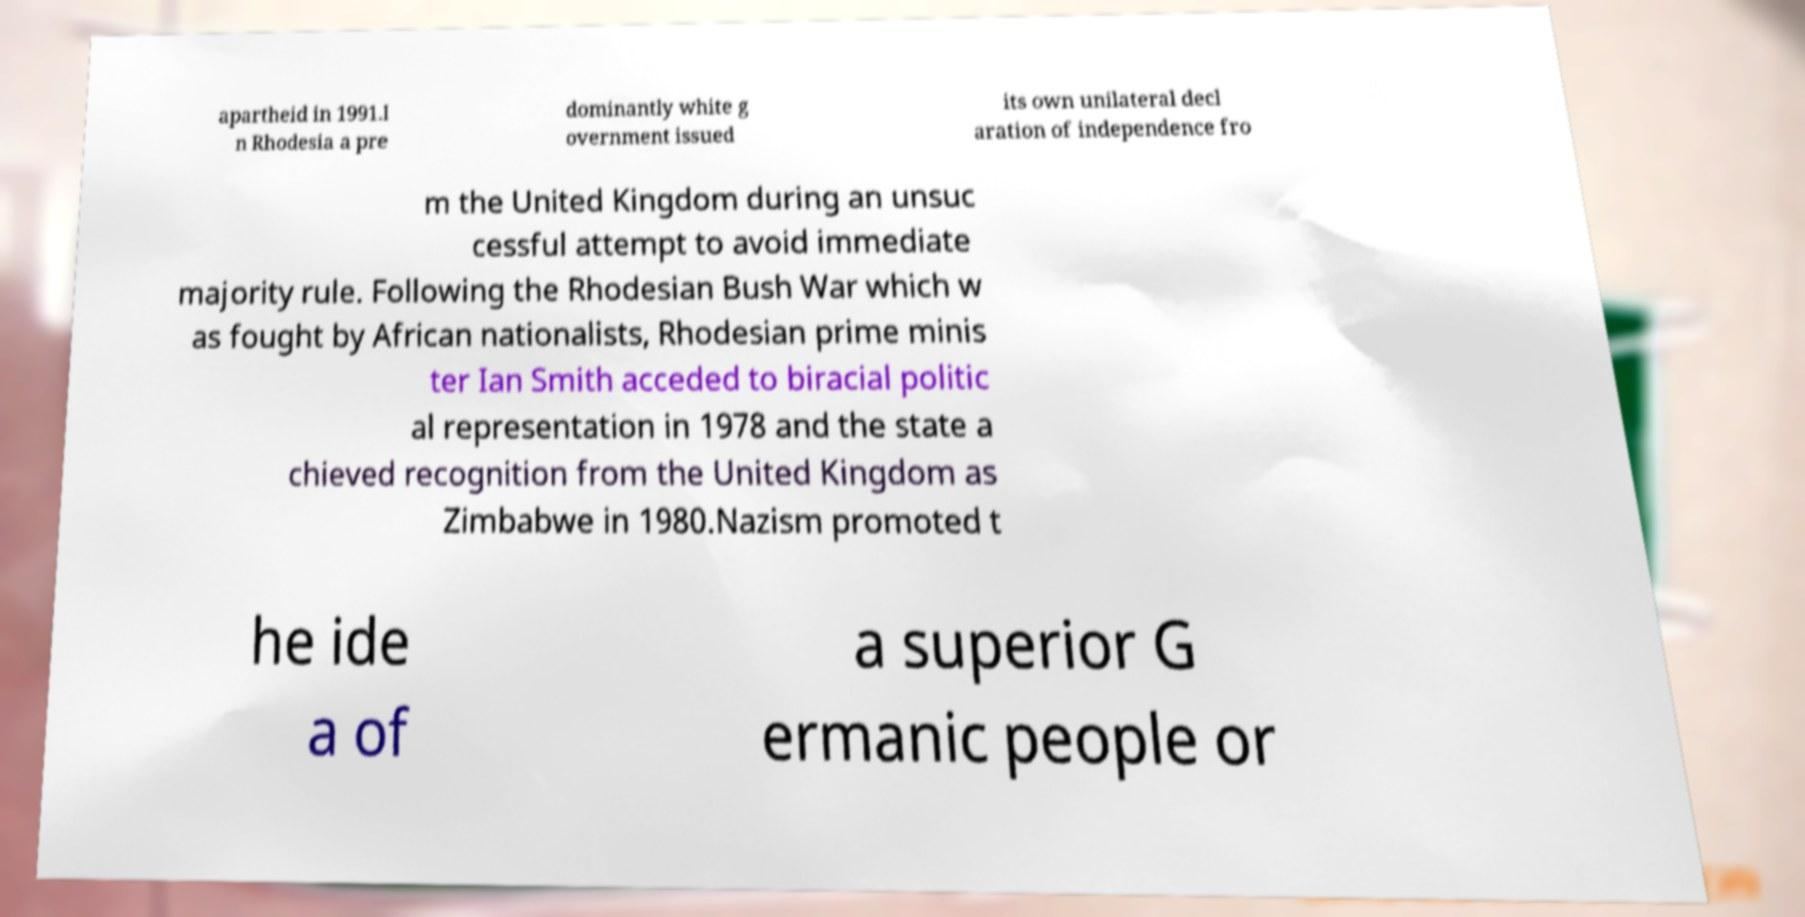Can you accurately transcribe the text from the provided image for me? apartheid in 1991.I n Rhodesia a pre dominantly white g overnment issued its own unilateral decl aration of independence fro m the United Kingdom during an unsuc cessful attempt to avoid immediate majority rule. Following the Rhodesian Bush War which w as fought by African nationalists, Rhodesian prime minis ter Ian Smith acceded to biracial politic al representation in 1978 and the state a chieved recognition from the United Kingdom as Zimbabwe in 1980.Nazism promoted t he ide a of a superior G ermanic people or 